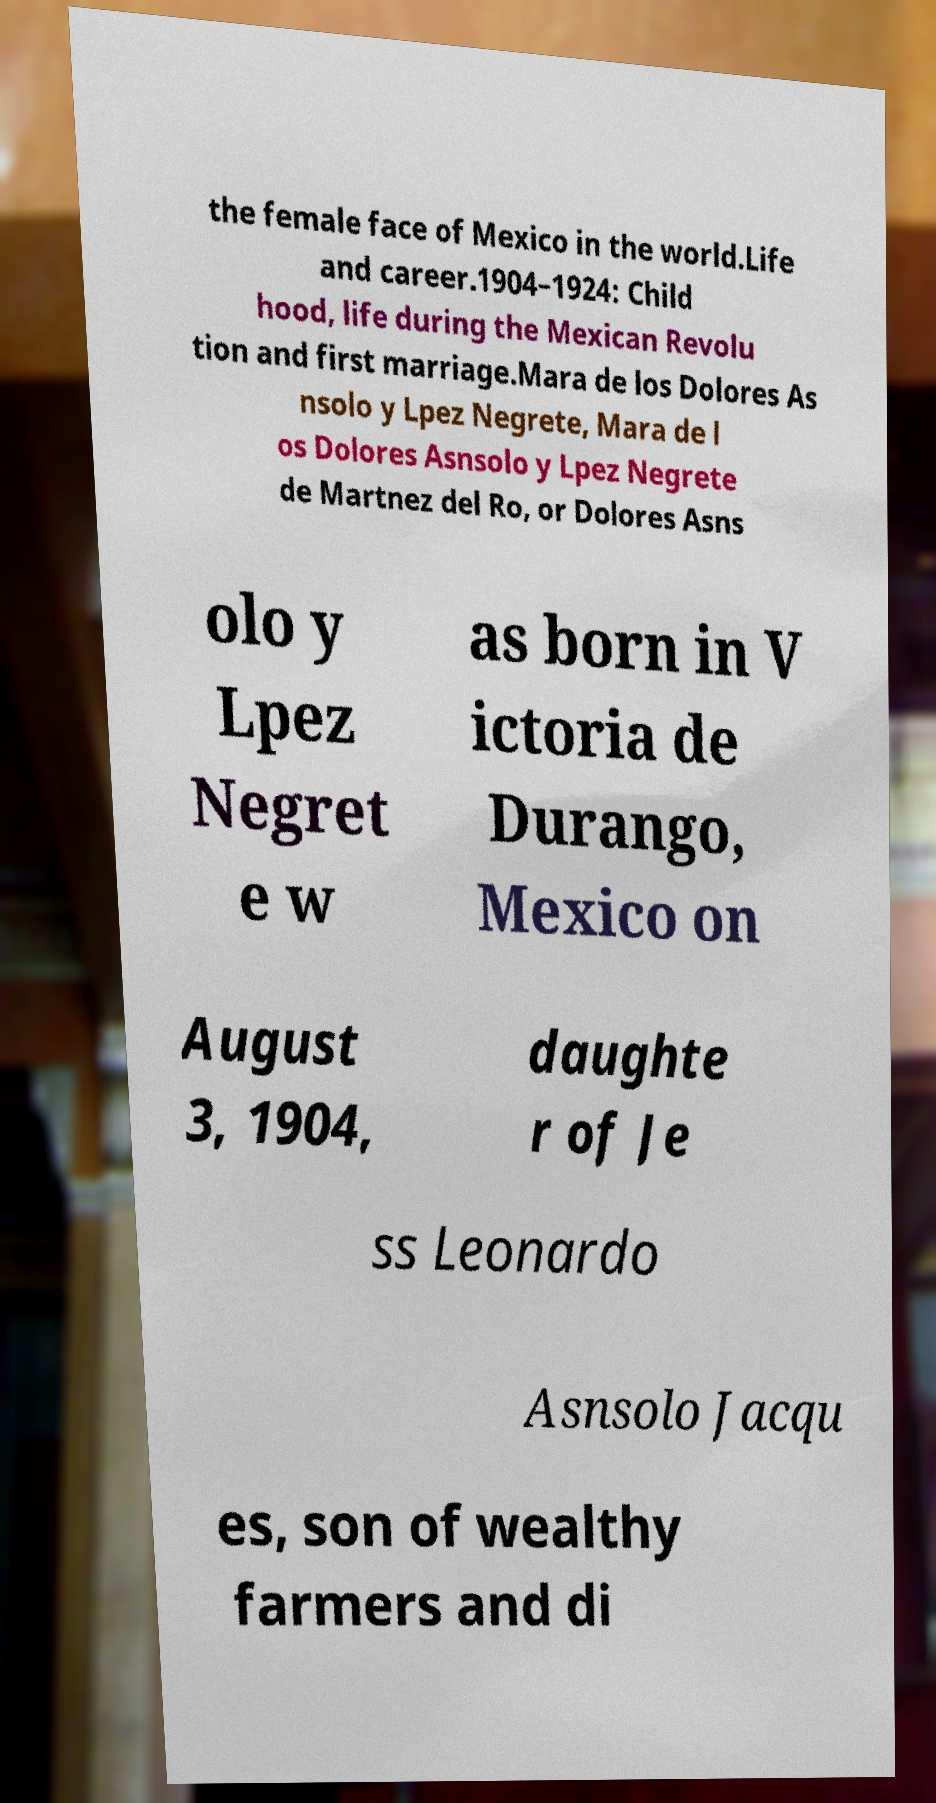For documentation purposes, I need the text within this image transcribed. Could you provide that? the female face of Mexico in the world.Life and career.1904–1924: Child hood, life during the Mexican Revolu tion and first marriage.Mara de los Dolores As nsolo y Lpez Negrete, Mara de l os Dolores Asnsolo y Lpez Negrete de Martnez del Ro, or Dolores Asns olo y Lpez Negret e w as born in V ictoria de Durango, Mexico on August 3, 1904, daughte r of Je ss Leonardo Asnsolo Jacqu es, son of wealthy farmers and di 